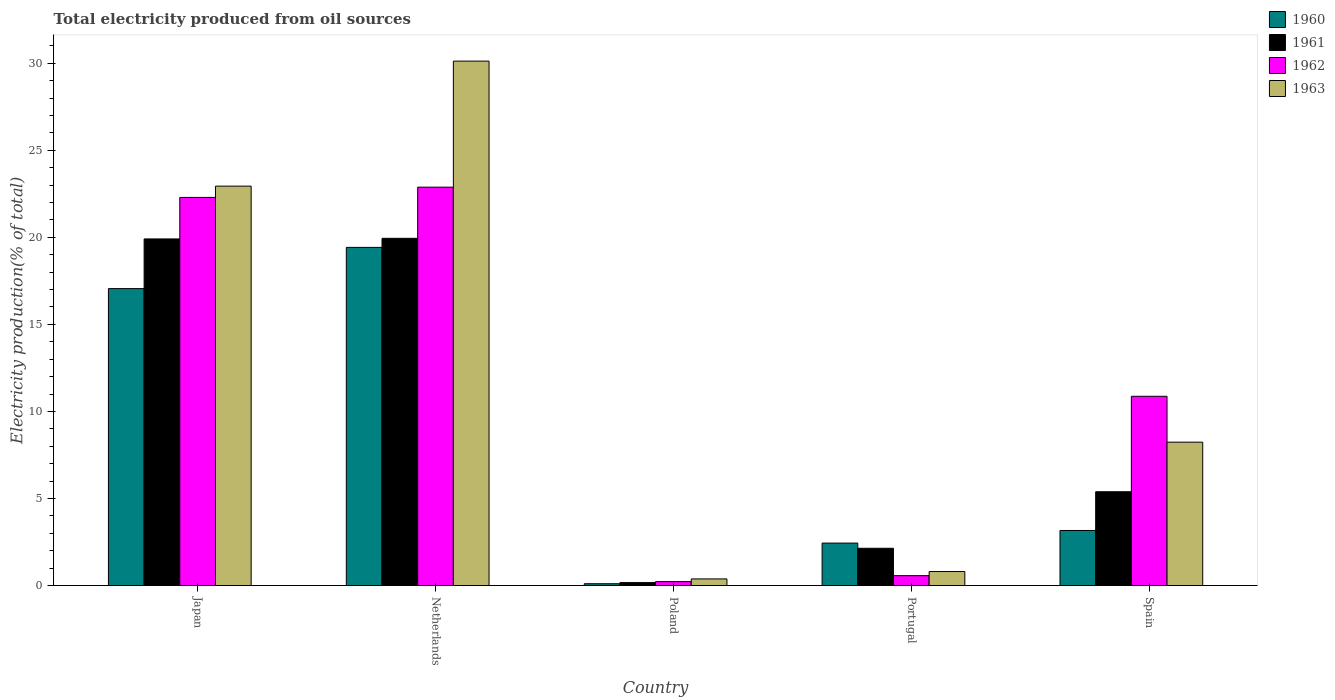How many different coloured bars are there?
Make the answer very short. 4. Are the number of bars per tick equal to the number of legend labels?
Make the answer very short. Yes. How many bars are there on the 1st tick from the left?
Ensure brevity in your answer.  4. How many bars are there on the 4th tick from the right?
Provide a short and direct response. 4. What is the label of the 5th group of bars from the left?
Provide a succinct answer. Spain. In how many cases, is the number of bars for a given country not equal to the number of legend labels?
Your answer should be very brief. 0. What is the total electricity produced in 1963 in Netherlands?
Keep it short and to the point. 30.12. Across all countries, what is the maximum total electricity produced in 1963?
Give a very brief answer. 30.12. Across all countries, what is the minimum total electricity produced in 1963?
Make the answer very short. 0.38. In which country was the total electricity produced in 1961 maximum?
Give a very brief answer. Netherlands. In which country was the total electricity produced in 1962 minimum?
Your answer should be compact. Poland. What is the total total electricity produced in 1963 in the graph?
Make the answer very short. 62.49. What is the difference between the total electricity produced in 1961 in Japan and that in Netherlands?
Keep it short and to the point. -0.04. What is the difference between the total electricity produced in 1962 in Poland and the total electricity produced in 1960 in Spain?
Give a very brief answer. -2.94. What is the average total electricity produced in 1963 per country?
Provide a short and direct response. 12.5. What is the difference between the total electricity produced of/in 1960 and total electricity produced of/in 1963 in Poland?
Your answer should be very brief. -0.28. In how many countries, is the total electricity produced in 1960 greater than 12 %?
Offer a very short reply. 2. What is the ratio of the total electricity produced in 1962 in Japan to that in Netherlands?
Your answer should be very brief. 0.97. Is the difference between the total electricity produced in 1960 in Japan and Poland greater than the difference between the total electricity produced in 1963 in Japan and Poland?
Ensure brevity in your answer.  No. What is the difference between the highest and the second highest total electricity produced in 1963?
Your response must be concise. -21.89. What is the difference between the highest and the lowest total electricity produced in 1960?
Your response must be concise. 19.32. Is the sum of the total electricity produced in 1960 in Poland and Portugal greater than the maximum total electricity produced in 1961 across all countries?
Your answer should be compact. No. Is it the case that in every country, the sum of the total electricity produced in 1962 and total electricity produced in 1963 is greater than the sum of total electricity produced in 1960 and total electricity produced in 1961?
Your response must be concise. No. What does the 1st bar from the left in Spain represents?
Provide a short and direct response. 1960. What does the 2nd bar from the right in Netherlands represents?
Ensure brevity in your answer.  1962. Is it the case that in every country, the sum of the total electricity produced in 1962 and total electricity produced in 1963 is greater than the total electricity produced in 1960?
Offer a very short reply. No. How many bars are there?
Your response must be concise. 20. How many countries are there in the graph?
Make the answer very short. 5. Does the graph contain any zero values?
Offer a terse response. No. Does the graph contain grids?
Your answer should be very brief. No. Where does the legend appear in the graph?
Your answer should be very brief. Top right. What is the title of the graph?
Make the answer very short. Total electricity produced from oil sources. What is the label or title of the X-axis?
Your answer should be compact. Country. What is the label or title of the Y-axis?
Your answer should be very brief. Electricity production(% of total). What is the Electricity production(% of total) in 1960 in Japan?
Your answer should be compact. 17.06. What is the Electricity production(% of total) in 1961 in Japan?
Your answer should be very brief. 19.91. What is the Electricity production(% of total) of 1962 in Japan?
Give a very brief answer. 22.29. What is the Electricity production(% of total) of 1963 in Japan?
Keep it short and to the point. 22.94. What is the Electricity production(% of total) in 1960 in Netherlands?
Keep it short and to the point. 19.42. What is the Electricity production(% of total) in 1961 in Netherlands?
Keep it short and to the point. 19.94. What is the Electricity production(% of total) in 1962 in Netherlands?
Your answer should be very brief. 22.88. What is the Electricity production(% of total) in 1963 in Netherlands?
Your answer should be compact. 30.12. What is the Electricity production(% of total) of 1960 in Poland?
Keep it short and to the point. 0.11. What is the Electricity production(% of total) in 1961 in Poland?
Your answer should be compact. 0.17. What is the Electricity production(% of total) of 1962 in Poland?
Ensure brevity in your answer.  0.23. What is the Electricity production(% of total) in 1963 in Poland?
Make the answer very short. 0.38. What is the Electricity production(% of total) of 1960 in Portugal?
Your answer should be very brief. 2.44. What is the Electricity production(% of total) of 1961 in Portugal?
Offer a very short reply. 2.14. What is the Electricity production(% of total) of 1962 in Portugal?
Offer a terse response. 0.57. What is the Electricity production(% of total) in 1963 in Portugal?
Ensure brevity in your answer.  0.81. What is the Electricity production(% of total) in 1960 in Spain?
Offer a terse response. 3.16. What is the Electricity production(% of total) in 1961 in Spain?
Offer a very short reply. 5.39. What is the Electricity production(% of total) in 1962 in Spain?
Your answer should be compact. 10.87. What is the Electricity production(% of total) of 1963 in Spain?
Provide a succinct answer. 8.24. Across all countries, what is the maximum Electricity production(% of total) in 1960?
Your response must be concise. 19.42. Across all countries, what is the maximum Electricity production(% of total) of 1961?
Offer a very short reply. 19.94. Across all countries, what is the maximum Electricity production(% of total) of 1962?
Your response must be concise. 22.88. Across all countries, what is the maximum Electricity production(% of total) in 1963?
Provide a short and direct response. 30.12. Across all countries, what is the minimum Electricity production(% of total) in 1960?
Ensure brevity in your answer.  0.11. Across all countries, what is the minimum Electricity production(% of total) of 1961?
Ensure brevity in your answer.  0.17. Across all countries, what is the minimum Electricity production(% of total) in 1962?
Your answer should be very brief. 0.23. Across all countries, what is the minimum Electricity production(% of total) of 1963?
Offer a very short reply. 0.38. What is the total Electricity production(% of total) of 1960 in the graph?
Offer a terse response. 42.19. What is the total Electricity production(% of total) of 1961 in the graph?
Ensure brevity in your answer.  47.55. What is the total Electricity production(% of total) of 1962 in the graph?
Ensure brevity in your answer.  56.84. What is the total Electricity production(% of total) of 1963 in the graph?
Offer a terse response. 62.49. What is the difference between the Electricity production(% of total) of 1960 in Japan and that in Netherlands?
Your response must be concise. -2.37. What is the difference between the Electricity production(% of total) in 1961 in Japan and that in Netherlands?
Your answer should be very brief. -0.04. What is the difference between the Electricity production(% of total) in 1962 in Japan and that in Netherlands?
Ensure brevity in your answer.  -0.59. What is the difference between the Electricity production(% of total) of 1963 in Japan and that in Netherlands?
Offer a terse response. -7.18. What is the difference between the Electricity production(% of total) of 1960 in Japan and that in Poland?
Give a very brief answer. 16.95. What is the difference between the Electricity production(% of total) of 1961 in Japan and that in Poland?
Provide a short and direct response. 19.74. What is the difference between the Electricity production(% of total) of 1962 in Japan and that in Poland?
Your response must be concise. 22.07. What is the difference between the Electricity production(% of total) of 1963 in Japan and that in Poland?
Offer a terse response. 22.56. What is the difference between the Electricity production(% of total) of 1960 in Japan and that in Portugal?
Provide a short and direct response. 14.62. What is the difference between the Electricity production(% of total) in 1961 in Japan and that in Portugal?
Keep it short and to the point. 17.77. What is the difference between the Electricity production(% of total) in 1962 in Japan and that in Portugal?
Offer a very short reply. 21.73. What is the difference between the Electricity production(% of total) in 1963 in Japan and that in Portugal?
Provide a short and direct response. 22.14. What is the difference between the Electricity production(% of total) in 1960 in Japan and that in Spain?
Give a very brief answer. 13.89. What is the difference between the Electricity production(% of total) in 1961 in Japan and that in Spain?
Provide a short and direct response. 14.52. What is the difference between the Electricity production(% of total) of 1962 in Japan and that in Spain?
Offer a very short reply. 11.42. What is the difference between the Electricity production(% of total) of 1963 in Japan and that in Spain?
Offer a very short reply. 14.71. What is the difference between the Electricity production(% of total) of 1960 in Netherlands and that in Poland?
Make the answer very short. 19.32. What is the difference between the Electricity production(% of total) of 1961 in Netherlands and that in Poland?
Keep it short and to the point. 19.77. What is the difference between the Electricity production(% of total) in 1962 in Netherlands and that in Poland?
Your answer should be compact. 22.66. What is the difference between the Electricity production(% of total) in 1963 in Netherlands and that in Poland?
Provide a succinct answer. 29.74. What is the difference between the Electricity production(% of total) in 1960 in Netherlands and that in Portugal?
Make the answer very short. 16.98. What is the difference between the Electricity production(% of total) of 1961 in Netherlands and that in Portugal?
Offer a terse response. 17.8. What is the difference between the Electricity production(% of total) of 1962 in Netherlands and that in Portugal?
Your response must be concise. 22.31. What is the difference between the Electricity production(% of total) of 1963 in Netherlands and that in Portugal?
Offer a very short reply. 29.32. What is the difference between the Electricity production(% of total) in 1960 in Netherlands and that in Spain?
Your response must be concise. 16.26. What is the difference between the Electricity production(% of total) of 1961 in Netherlands and that in Spain?
Make the answer very short. 14.56. What is the difference between the Electricity production(% of total) of 1962 in Netherlands and that in Spain?
Keep it short and to the point. 12.01. What is the difference between the Electricity production(% of total) of 1963 in Netherlands and that in Spain?
Provide a succinct answer. 21.89. What is the difference between the Electricity production(% of total) in 1960 in Poland and that in Portugal?
Make the answer very short. -2.33. What is the difference between the Electricity production(% of total) in 1961 in Poland and that in Portugal?
Provide a succinct answer. -1.97. What is the difference between the Electricity production(% of total) of 1962 in Poland and that in Portugal?
Your answer should be compact. -0.34. What is the difference between the Electricity production(% of total) of 1963 in Poland and that in Portugal?
Your answer should be compact. -0.42. What is the difference between the Electricity production(% of total) of 1960 in Poland and that in Spain?
Offer a very short reply. -3.06. What is the difference between the Electricity production(% of total) of 1961 in Poland and that in Spain?
Keep it short and to the point. -5.22. What is the difference between the Electricity production(% of total) of 1962 in Poland and that in Spain?
Provide a short and direct response. -10.64. What is the difference between the Electricity production(% of total) in 1963 in Poland and that in Spain?
Make the answer very short. -7.85. What is the difference between the Electricity production(% of total) in 1960 in Portugal and that in Spain?
Make the answer very short. -0.72. What is the difference between the Electricity production(% of total) in 1961 in Portugal and that in Spain?
Make the answer very short. -3.25. What is the difference between the Electricity production(% of total) in 1962 in Portugal and that in Spain?
Provide a short and direct response. -10.3. What is the difference between the Electricity production(% of total) in 1963 in Portugal and that in Spain?
Keep it short and to the point. -7.43. What is the difference between the Electricity production(% of total) of 1960 in Japan and the Electricity production(% of total) of 1961 in Netherlands?
Offer a very short reply. -2.89. What is the difference between the Electricity production(% of total) of 1960 in Japan and the Electricity production(% of total) of 1962 in Netherlands?
Provide a short and direct response. -5.83. What is the difference between the Electricity production(% of total) in 1960 in Japan and the Electricity production(% of total) in 1963 in Netherlands?
Your answer should be very brief. -13.07. What is the difference between the Electricity production(% of total) in 1961 in Japan and the Electricity production(% of total) in 1962 in Netherlands?
Keep it short and to the point. -2.97. What is the difference between the Electricity production(% of total) of 1961 in Japan and the Electricity production(% of total) of 1963 in Netherlands?
Provide a short and direct response. -10.21. What is the difference between the Electricity production(% of total) in 1962 in Japan and the Electricity production(% of total) in 1963 in Netherlands?
Keep it short and to the point. -7.83. What is the difference between the Electricity production(% of total) of 1960 in Japan and the Electricity production(% of total) of 1961 in Poland?
Your answer should be very brief. 16.89. What is the difference between the Electricity production(% of total) of 1960 in Japan and the Electricity production(% of total) of 1962 in Poland?
Offer a very short reply. 16.83. What is the difference between the Electricity production(% of total) in 1960 in Japan and the Electricity production(% of total) in 1963 in Poland?
Your response must be concise. 16.67. What is the difference between the Electricity production(% of total) of 1961 in Japan and the Electricity production(% of total) of 1962 in Poland?
Ensure brevity in your answer.  19.68. What is the difference between the Electricity production(% of total) in 1961 in Japan and the Electricity production(% of total) in 1963 in Poland?
Give a very brief answer. 19.53. What is the difference between the Electricity production(% of total) of 1962 in Japan and the Electricity production(% of total) of 1963 in Poland?
Provide a short and direct response. 21.91. What is the difference between the Electricity production(% of total) in 1960 in Japan and the Electricity production(% of total) in 1961 in Portugal?
Keep it short and to the point. 14.91. What is the difference between the Electricity production(% of total) of 1960 in Japan and the Electricity production(% of total) of 1962 in Portugal?
Offer a terse response. 16.49. What is the difference between the Electricity production(% of total) of 1960 in Japan and the Electricity production(% of total) of 1963 in Portugal?
Your answer should be compact. 16.25. What is the difference between the Electricity production(% of total) in 1961 in Japan and the Electricity production(% of total) in 1962 in Portugal?
Provide a short and direct response. 19.34. What is the difference between the Electricity production(% of total) in 1961 in Japan and the Electricity production(% of total) in 1963 in Portugal?
Offer a terse response. 19.1. What is the difference between the Electricity production(% of total) in 1962 in Japan and the Electricity production(% of total) in 1963 in Portugal?
Keep it short and to the point. 21.49. What is the difference between the Electricity production(% of total) in 1960 in Japan and the Electricity production(% of total) in 1961 in Spain?
Offer a very short reply. 11.67. What is the difference between the Electricity production(% of total) of 1960 in Japan and the Electricity production(% of total) of 1962 in Spain?
Give a very brief answer. 6.19. What is the difference between the Electricity production(% of total) of 1960 in Japan and the Electricity production(% of total) of 1963 in Spain?
Your answer should be very brief. 8.82. What is the difference between the Electricity production(% of total) in 1961 in Japan and the Electricity production(% of total) in 1962 in Spain?
Provide a short and direct response. 9.04. What is the difference between the Electricity production(% of total) of 1961 in Japan and the Electricity production(% of total) of 1963 in Spain?
Keep it short and to the point. 11.67. What is the difference between the Electricity production(% of total) in 1962 in Japan and the Electricity production(% of total) in 1963 in Spain?
Offer a very short reply. 14.06. What is the difference between the Electricity production(% of total) in 1960 in Netherlands and the Electricity production(% of total) in 1961 in Poland?
Your answer should be compact. 19.25. What is the difference between the Electricity production(% of total) in 1960 in Netherlands and the Electricity production(% of total) in 1962 in Poland?
Your answer should be compact. 19.2. What is the difference between the Electricity production(% of total) of 1960 in Netherlands and the Electricity production(% of total) of 1963 in Poland?
Offer a very short reply. 19.04. What is the difference between the Electricity production(% of total) in 1961 in Netherlands and the Electricity production(% of total) in 1962 in Poland?
Make the answer very short. 19.72. What is the difference between the Electricity production(% of total) of 1961 in Netherlands and the Electricity production(% of total) of 1963 in Poland?
Your response must be concise. 19.56. What is the difference between the Electricity production(% of total) in 1962 in Netherlands and the Electricity production(% of total) in 1963 in Poland?
Your response must be concise. 22.5. What is the difference between the Electricity production(% of total) of 1960 in Netherlands and the Electricity production(% of total) of 1961 in Portugal?
Provide a short and direct response. 17.28. What is the difference between the Electricity production(% of total) of 1960 in Netherlands and the Electricity production(% of total) of 1962 in Portugal?
Provide a short and direct response. 18.86. What is the difference between the Electricity production(% of total) in 1960 in Netherlands and the Electricity production(% of total) in 1963 in Portugal?
Offer a terse response. 18.62. What is the difference between the Electricity production(% of total) of 1961 in Netherlands and the Electricity production(% of total) of 1962 in Portugal?
Offer a very short reply. 19.38. What is the difference between the Electricity production(% of total) of 1961 in Netherlands and the Electricity production(% of total) of 1963 in Portugal?
Your answer should be very brief. 19.14. What is the difference between the Electricity production(% of total) of 1962 in Netherlands and the Electricity production(% of total) of 1963 in Portugal?
Keep it short and to the point. 22.08. What is the difference between the Electricity production(% of total) of 1960 in Netherlands and the Electricity production(% of total) of 1961 in Spain?
Keep it short and to the point. 14.04. What is the difference between the Electricity production(% of total) in 1960 in Netherlands and the Electricity production(% of total) in 1962 in Spain?
Give a very brief answer. 8.55. What is the difference between the Electricity production(% of total) in 1960 in Netherlands and the Electricity production(% of total) in 1963 in Spain?
Give a very brief answer. 11.19. What is the difference between the Electricity production(% of total) of 1961 in Netherlands and the Electricity production(% of total) of 1962 in Spain?
Give a very brief answer. 9.07. What is the difference between the Electricity production(% of total) of 1961 in Netherlands and the Electricity production(% of total) of 1963 in Spain?
Give a very brief answer. 11.71. What is the difference between the Electricity production(% of total) of 1962 in Netherlands and the Electricity production(% of total) of 1963 in Spain?
Keep it short and to the point. 14.65. What is the difference between the Electricity production(% of total) of 1960 in Poland and the Electricity production(% of total) of 1961 in Portugal?
Your answer should be compact. -2.04. What is the difference between the Electricity production(% of total) in 1960 in Poland and the Electricity production(% of total) in 1962 in Portugal?
Your answer should be compact. -0.46. What is the difference between the Electricity production(% of total) in 1960 in Poland and the Electricity production(% of total) in 1963 in Portugal?
Offer a terse response. -0.7. What is the difference between the Electricity production(% of total) in 1961 in Poland and the Electricity production(% of total) in 1962 in Portugal?
Offer a very short reply. -0.4. What is the difference between the Electricity production(% of total) of 1961 in Poland and the Electricity production(% of total) of 1963 in Portugal?
Your answer should be very brief. -0.63. What is the difference between the Electricity production(% of total) in 1962 in Poland and the Electricity production(% of total) in 1963 in Portugal?
Provide a short and direct response. -0.58. What is the difference between the Electricity production(% of total) in 1960 in Poland and the Electricity production(% of total) in 1961 in Spain?
Keep it short and to the point. -5.28. What is the difference between the Electricity production(% of total) of 1960 in Poland and the Electricity production(% of total) of 1962 in Spain?
Offer a terse response. -10.77. What is the difference between the Electricity production(% of total) of 1960 in Poland and the Electricity production(% of total) of 1963 in Spain?
Your answer should be very brief. -8.13. What is the difference between the Electricity production(% of total) of 1961 in Poland and the Electricity production(% of total) of 1962 in Spain?
Offer a very short reply. -10.7. What is the difference between the Electricity production(% of total) in 1961 in Poland and the Electricity production(% of total) in 1963 in Spain?
Give a very brief answer. -8.07. What is the difference between the Electricity production(% of total) in 1962 in Poland and the Electricity production(% of total) in 1963 in Spain?
Your answer should be compact. -8.01. What is the difference between the Electricity production(% of total) in 1960 in Portugal and the Electricity production(% of total) in 1961 in Spain?
Your answer should be compact. -2.95. What is the difference between the Electricity production(% of total) in 1960 in Portugal and the Electricity production(% of total) in 1962 in Spain?
Ensure brevity in your answer.  -8.43. What is the difference between the Electricity production(% of total) of 1960 in Portugal and the Electricity production(% of total) of 1963 in Spain?
Give a very brief answer. -5.8. What is the difference between the Electricity production(% of total) of 1961 in Portugal and the Electricity production(% of total) of 1962 in Spain?
Ensure brevity in your answer.  -8.73. What is the difference between the Electricity production(% of total) of 1961 in Portugal and the Electricity production(% of total) of 1963 in Spain?
Keep it short and to the point. -6.09. What is the difference between the Electricity production(% of total) in 1962 in Portugal and the Electricity production(% of total) in 1963 in Spain?
Make the answer very short. -7.67. What is the average Electricity production(% of total) in 1960 per country?
Provide a short and direct response. 8.44. What is the average Electricity production(% of total) of 1961 per country?
Your answer should be compact. 9.51. What is the average Electricity production(% of total) in 1962 per country?
Give a very brief answer. 11.37. What is the average Electricity production(% of total) in 1963 per country?
Give a very brief answer. 12.5. What is the difference between the Electricity production(% of total) in 1960 and Electricity production(% of total) in 1961 in Japan?
Offer a very short reply. -2.85. What is the difference between the Electricity production(% of total) in 1960 and Electricity production(% of total) in 1962 in Japan?
Give a very brief answer. -5.24. What is the difference between the Electricity production(% of total) in 1960 and Electricity production(% of total) in 1963 in Japan?
Keep it short and to the point. -5.89. What is the difference between the Electricity production(% of total) of 1961 and Electricity production(% of total) of 1962 in Japan?
Provide a succinct answer. -2.38. What is the difference between the Electricity production(% of total) of 1961 and Electricity production(% of total) of 1963 in Japan?
Provide a succinct answer. -3.03. What is the difference between the Electricity production(% of total) in 1962 and Electricity production(% of total) in 1963 in Japan?
Provide a succinct answer. -0.65. What is the difference between the Electricity production(% of total) of 1960 and Electricity production(% of total) of 1961 in Netherlands?
Offer a terse response. -0.52. What is the difference between the Electricity production(% of total) in 1960 and Electricity production(% of total) in 1962 in Netherlands?
Make the answer very short. -3.46. What is the difference between the Electricity production(% of total) in 1960 and Electricity production(% of total) in 1963 in Netherlands?
Your answer should be compact. -10.7. What is the difference between the Electricity production(% of total) of 1961 and Electricity production(% of total) of 1962 in Netherlands?
Ensure brevity in your answer.  -2.94. What is the difference between the Electricity production(% of total) of 1961 and Electricity production(% of total) of 1963 in Netherlands?
Ensure brevity in your answer.  -10.18. What is the difference between the Electricity production(% of total) of 1962 and Electricity production(% of total) of 1963 in Netherlands?
Give a very brief answer. -7.24. What is the difference between the Electricity production(% of total) in 1960 and Electricity production(% of total) in 1961 in Poland?
Give a very brief answer. -0.06. What is the difference between the Electricity production(% of total) of 1960 and Electricity production(% of total) of 1962 in Poland?
Give a very brief answer. -0.12. What is the difference between the Electricity production(% of total) of 1960 and Electricity production(% of total) of 1963 in Poland?
Ensure brevity in your answer.  -0.28. What is the difference between the Electricity production(% of total) of 1961 and Electricity production(% of total) of 1962 in Poland?
Your response must be concise. -0.06. What is the difference between the Electricity production(% of total) of 1961 and Electricity production(% of total) of 1963 in Poland?
Your answer should be very brief. -0.21. What is the difference between the Electricity production(% of total) of 1962 and Electricity production(% of total) of 1963 in Poland?
Offer a very short reply. -0.16. What is the difference between the Electricity production(% of total) of 1960 and Electricity production(% of total) of 1961 in Portugal?
Your response must be concise. 0.3. What is the difference between the Electricity production(% of total) in 1960 and Electricity production(% of total) in 1962 in Portugal?
Offer a very short reply. 1.87. What is the difference between the Electricity production(% of total) in 1960 and Electricity production(% of total) in 1963 in Portugal?
Your answer should be compact. 1.63. What is the difference between the Electricity production(% of total) in 1961 and Electricity production(% of total) in 1962 in Portugal?
Offer a terse response. 1.57. What is the difference between the Electricity production(% of total) of 1961 and Electricity production(% of total) of 1963 in Portugal?
Keep it short and to the point. 1.34. What is the difference between the Electricity production(% of total) of 1962 and Electricity production(% of total) of 1963 in Portugal?
Give a very brief answer. -0.24. What is the difference between the Electricity production(% of total) in 1960 and Electricity production(% of total) in 1961 in Spain?
Your response must be concise. -2.22. What is the difference between the Electricity production(% of total) in 1960 and Electricity production(% of total) in 1962 in Spain?
Keep it short and to the point. -7.71. What is the difference between the Electricity production(% of total) in 1960 and Electricity production(% of total) in 1963 in Spain?
Make the answer very short. -5.07. What is the difference between the Electricity production(% of total) in 1961 and Electricity production(% of total) in 1962 in Spain?
Your answer should be compact. -5.48. What is the difference between the Electricity production(% of total) in 1961 and Electricity production(% of total) in 1963 in Spain?
Your response must be concise. -2.85. What is the difference between the Electricity production(% of total) in 1962 and Electricity production(% of total) in 1963 in Spain?
Provide a succinct answer. 2.63. What is the ratio of the Electricity production(% of total) of 1960 in Japan to that in Netherlands?
Make the answer very short. 0.88. What is the ratio of the Electricity production(% of total) in 1961 in Japan to that in Netherlands?
Ensure brevity in your answer.  1. What is the ratio of the Electricity production(% of total) in 1962 in Japan to that in Netherlands?
Ensure brevity in your answer.  0.97. What is the ratio of the Electricity production(% of total) of 1963 in Japan to that in Netherlands?
Offer a very short reply. 0.76. What is the ratio of the Electricity production(% of total) in 1960 in Japan to that in Poland?
Give a very brief answer. 161.11. What is the ratio of the Electricity production(% of total) of 1961 in Japan to that in Poland?
Keep it short and to the point. 116.7. What is the ratio of the Electricity production(% of total) of 1962 in Japan to that in Poland?
Keep it short and to the point. 98.55. What is the ratio of the Electricity production(% of total) in 1963 in Japan to that in Poland?
Provide a succinct answer. 60.11. What is the ratio of the Electricity production(% of total) in 1960 in Japan to that in Portugal?
Provide a short and direct response. 6.99. What is the ratio of the Electricity production(% of total) of 1961 in Japan to that in Portugal?
Your answer should be very brief. 9.3. What is the ratio of the Electricity production(% of total) in 1962 in Japan to that in Portugal?
Your answer should be very brief. 39.24. What is the ratio of the Electricity production(% of total) of 1963 in Japan to that in Portugal?
Keep it short and to the point. 28.49. What is the ratio of the Electricity production(% of total) of 1960 in Japan to that in Spain?
Provide a short and direct response. 5.39. What is the ratio of the Electricity production(% of total) in 1961 in Japan to that in Spain?
Make the answer very short. 3.69. What is the ratio of the Electricity production(% of total) of 1962 in Japan to that in Spain?
Make the answer very short. 2.05. What is the ratio of the Electricity production(% of total) of 1963 in Japan to that in Spain?
Provide a succinct answer. 2.79. What is the ratio of the Electricity production(% of total) in 1960 in Netherlands to that in Poland?
Give a very brief answer. 183.47. What is the ratio of the Electricity production(% of total) in 1961 in Netherlands to that in Poland?
Your answer should be very brief. 116.91. What is the ratio of the Electricity production(% of total) in 1962 in Netherlands to that in Poland?
Keep it short and to the point. 101.15. What is the ratio of the Electricity production(% of total) in 1963 in Netherlands to that in Poland?
Ensure brevity in your answer.  78.92. What is the ratio of the Electricity production(% of total) of 1960 in Netherlands to that in Portugal?
Your response must be concise. 7.96. What is the ratio of the Electricity production(% of total) of 1961 in Netherlands to that in Portugal?
Your answer should be very brief. 9.31. What is the ratio of the Electricity production(% of total) in 1962 in Netherlands to that in Portugal?
Provide a succinct answer. 40.27. What is the ratio of the Electricity production(% of total) in 1963 in Netherlands to that in Portugal?
Provide a short and direct response. 37.4. What is the ratio of the Electricity production(% of total) of 1960 in Netherlands to that in Spain?
Your response must be concise. 6.14. What is the ratio of the Electricity production(% of total) in 1961 in Netherlands to that in Spain?
Provide a short and direct response. 3.7. What is the ratio of the Electricity production(% of total) of 1962 in Netherlands to that in Spain?
Make the answer very short. 2.1. What is the ratio of the Electricity production(% of total) in 1963 in Netherlands to that in Spain?
Give a very brief answer. 3.66. What is the ratio of the Electricity production(% of total) in 1960 in Poland to that in Portugal?
Your response must be concise. 0.04. What is the ratio of the Electricity production(% of total) in 1961 in Poland to that in Portugal?
Your answer should be very brief. 0.08. What is the ratio of the Electricity production(% of total) of 1962 in Poland to that in Portugal?
Provide a succinct answer. 0.4. What is the ratio of the Electricity production(% of total) of 1963 in Poland to that in Portugal?
Keep it short and to the point. 0.47. What is the ratio of the Electricity production(% of total) of 1960 in Poland to that in Spain?
Offer a very short reply. 0.03. What is the ratio of the Electricity production(% of total) in 1961 in Poland to that in Spain?
Make the answer very short. 0.03. What is the ratio of the Electricity production(% of total) in 1962 in Poland to that in Spain?
Keep it short and to the point. 0.02. What is the ratio of the Electricity production(% of total) in 1963 in Poland to that in Spain?
Offer a terse response. 0.05. What is the ratio of the Electricity production(% of total) in 1960 in Portugal to that in Spain?
Your answer should be compact. 0.77. What is the ratio of the Electricity production(% of total) of 1961 in Portugal to that in Spain?
Provide a succinct answer. 0.4. What is the ratio of the Electricity production(% of total) in 1962 in Portugal to that in Spain?
Provide a succinct answer. 0.05. What is the ratio of the Electricity production(% of total) of 1963 in Portugal to that in Spain?
Make the answer very short. 0.1. What is the difference between the highest and the second highest Electricity production(% of total) in 1960?
Ensure brevity in your answer.  2.37. What is the difference between the highest and the second highest Electricity production(% of total) in 1961?
Your response must be concise. 0.04. What is the difference between the highest and the second highest Electricity production(% of total) of 1962?
Give a very brief answer. 0.59. What is the difference between the highest and the second highest Electricity production(% of total) in 1963?
Keep it short and to the point. 7.18. What is the difference between the highest and the lowest Electricity production(% of total) in 1960?
Ensure brevity in your answer.  19.32. What is the difference between the highest and the lowest Electricity production(% of total) in 1961?
Provide a short and direct response. 19.77. What is the difference between the highest and the lowest Electricity production(% of total) of 1962?
Keep it short and to the point. 22.66. What is the difference between the highest and the lowest Electricity production(% of total) of 1963?
Offer a terse response. 29.74. 